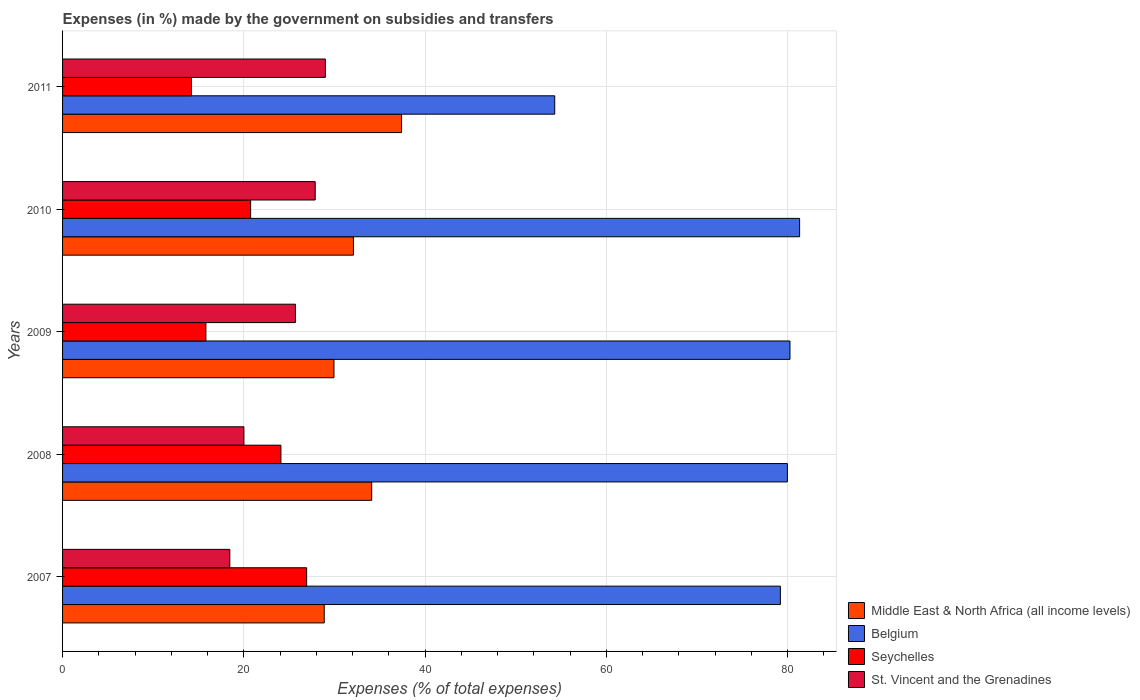How many groups of bars are there?
Provide a short and direct response. 5. Are the number of bars on each tick of the Y-axis equal?
Give a very brief answer. Yes. In how many cases, is the number of bars for a given year not equal to the number of legend labels?
Ensure brevity in your answer.  0. What is the percentage of expenses made by the government on subsidies and transfers in Belgium in 2011?
Make the answer very short. 54.3. Across all years, what is the maximum percentage of expenses made by the government on subsidies and transfers in Middle East & North Africa (all income levels)?
Keep it short and to the point. 37.4. Across all years, what is the minimum percentage of expenses made by the government on subsidies and transfers in Belgium?
Your response must be concise. 54.3. What is the total percentage of expenses made by the government on subsidies and transfers in Belgium in the graph?
Offer a very short reply. 375.04. What is the difference between the percentage of expenses made by the government on subsidies and transfers in Belgium in 2010 and that in 2011?
Provide a succinct answer. 27.02. What is the difference between the percentage of expenses made by the government on subsidies and transfers in Seychelles in 2009 and the percentage of expenses made by the government on subsidies and transfers in Middle East & North Africa (all income levels) in 2011?
Keep it short and to the point. -21.59. What is the average percentage of expenses made by the government on subsidies and transfers in Belgium per year?
Keep it short and to the point. 75.01. In the year 2007, what is the difference between the percentage of expenses made by the government on subsidies and transfers in Seychelles and percentage of expenses made by the government on subsidies and transfers in Belgium?
Ensure brevity in your answer.  -52.27. In how many years, is the percentage of expenses made by the government on subsidies and transfers in Middle East & North Africa (all income levels) greater than 40 %?
Ensure brevity in your answer.  0. What is the ratio of the percentage of expenses made by the government on subsidies and transfers in Belgium in 2009 to that in 2010?
Your response must be concise. 0.99. What is the difference between the highest and the second highest percentage of expenses made by the government on subsidies and transfers in Belgium?
Give a very brief answer. 1.06. What is the difference between the highest and the lowest percentage of expenses made by the government on subsidies and transfers in Belgium?
Give a very brief answer. 27.02. In how many years, is the percentage of expenses made by the government on subsidies and transfers in Middle East & North Africa (all income levels) greater than the average percentage of expenses made by the government on subsidies and transfers in Middle East & North Africa (all income levels) taken over all years?
Provide a succinct answer. 2. What does the 3rd bar from the top in 2007 represents?
Offer a very short reply. Belgium. What does the 3rd bar from the bottom in 2011 represents?
Your response must be concise. Seychelles. Is it the case that in every year, the sum of the percentage of expenses made by the government on subsidies and transfers in Belgium and percentage of expenses made by the government on subsidies and transfers in St. Vincent and the Grenadines is greater than the percentage of expenses made by the government on subsidies and transfers in Seychelles?
Ensure brevity in your answer.  Yes. How many bars are there?
Your response must be concise. 20. Are all the bars in the graph horizontal?
Your answer should be compact. Yes. How many years are there in the graph?
Your answer should be very brief. 5. What is the difference between two consecutive major ticks on the X-axis?
Provide a succinct answer. 20. What is the title of the graph?
Ensure brevity in your answer.  Expenses (in %) made by the government on subsidies and transfers. Does "Kosovo" appear as one of the legend labels in the graph?
Provide a short and direct response. No. What is the label or title of the X-axis?
Offer a very short reply. Expenses (% of total expenses). What is the Expenses (% of total expenses) of Middle East & North Africa (all income levels) in 2007?
Ensure brevity in your answer.  28.87. What is the Expenses (% of total expenses) of Belgium in 2007?
Make the answer very short. 79.2. What is the Expenses (% of total expenses) in Seychelles in 2007?
Your answer should be compact. 26.93. What is the Expenses (% of total expenses) in St. Vincent and the Grenadines in 2007?
Provide a succinct answer. 18.45. What is the Expenses (% of total expenses) in Middle East & North Africa (all income levels) in 2008?
Offer a terse response. 34.11. What is the Expenses (% of total expenses) of Belgium in 2008?
Provide a succinct answer. 79.97. What is the Expenses (% of total expenses) of Seychelles in 2008?
Give a very brief answer. 24.09. What is the Expenses (% of total expenses) of St. Vincent and the Grenadines in 2008?
Make the answer very short. 20.01. What is the Expenses (% of total expenses) in Middle East & North Africa (all income levels) in 2009?
Keep it short and to the point. 29.94. What is the Expenses (% of total expenses) of Belgium in 2009?
Ensure brevity in your answer.  80.26. What is the Expenses (% of total expenses) of Seychelles in 2009?
Make the answer very short. 15.81. What is the Expenses (% of total expenses) of St. Vincent and the Grenadines in 2009?
Make the answer very short. 25.69. What is the Expenses (% of total expenses) of Middle East & North Africa (all income levels) in 2010?
Give a very brief answer. 32.09. What is the Expenses (% of total expenses) of Belgium in 2010?
Provide a short and direct response. 81.32. What is the Expenses (% of total expenses) in Seychelles in 2010?
Keep it short and to the point. 20.75. What is the Expenses (% of total expenses) of St. Vincent and the Grenadines in 2010?
Provide a succinct answer. 27.87. What is the Expenses (% of total expenses) of Middle East & North Africa (all income levels) in 2011?
Provide a short and direct response. 37.4. What is the Expenses (% of total expenses) of Belgium in 2011?
Ensure brevity in your answer.  54.3. What is the Expenses (% of total expenses) of Seychelles in 2011?
Ensure brevity in your answer.  14.23. What is the Expenses (% of total expenses) of St. Vincent and the Grenadines in 2011?
Offer a very short reply. 29. Across all years, what is the maximum Expenses (% of total expenses) of Middle East & North Africa (all income levels)?
Ensure brevity in your answer.  37.4. Across all years, what is the maximum Expenses (% of total expenses) in Belgium?
Offer a very short reply. 81.32. Across all years, what is the maximum Expenses (% of total expenses) of Seychelles?
Provide a short and direct response. 26.93. Across all years, what is the maximum Expenses (% of total expenses) in St. Vincent and the Grenadines?
Ensure brevity in your answer.  29. Across all years, what is the minimum Expenses (% of total expenses) of Middle East & North Africa (all income levels)?
Keep it short and to the point. 28.87. Across all years, what is the minimum Expenses (% of total expenses) in Belgium?
Your answer should be very brief. 54.3. Across all years, what is the minimum Expenses (% of total expenses) in Seychelles?
Provide a short and direct response. 14.23. Across all years, what is the minimum Expenses (% of total expenses) in St. Vincent and the Grenadines?
Offer a very short reply. 18.45. What is the total Expenses (% of total expenses) of Middle East & North Africa (all income levels) in the graph?
Give a very brief answer. 162.42. What is the total Expenses (% of total expenses) in Belgium in the graph?
Keep it short and to the point. 375.04. What is the total Expenses (% of total expenses) of Seychelles in the graph?
Provide a succinct answer. 101.81. What is the total Expenses (% of total expenses) of St. Vincent and the Grenadines in the graph?
Your answer should be very brief. 121.03. What is the difference between the Expenses (% of total expenses) of Middle East & North Africa (all income levels) in 2007 and that in 2008?
Your answer should be very brief. -5.24. What is the difference between the Expenses (% of total expenses) of Belgium in 2007 and that in 2008?
Keep it short and to the point. -0.77. What is the difference between the Expenses (% of total expenses) in Seychelles in 2007 and that in 2008?
Provide a succinct answer. 2.84. What is the difference between the Expenses (% of total expenses) of St. Vincent and the Grenadines in 2007 and that in 2008?
Offer a very short reply. -1.56. What is the difference between the Expenses (% of total expenses) of Middle East & North Africa (all income levels) in 2007 and that in 2009?
Your answer should be very brief. -1.07. What is the difference between the Expenses (% of total expenses) in Belgium in 2007 and that in 2009?
Give a very brief answer. -1.06. What is the difference between the Expenses (% of total expenses) of Seychelles in 2007 and that in 2009?
Give a very brief answer. 11.11. What is the difference between the Expenses (% of total expenses) in St. Vincent and the Grenadines in 2007 and that in 2009?
Your response must be concise. -7.24. What is the difference between the Expenses (% of total expenses) in Middle East & North Africa (all income levels) in 2007 and that in 2010?
Provide a short and direct response. -3.22. What is the difference between the Expenses (% of total expenses) in Belgium in 2007 and that in 2010?
Provide a succinct answer. -2.12. What is the difference between the Expenses (% of total expenses) in Seychelles in 2007 and that in 2010?
Ensure brevity in your answer.  6.18. What is the difference between the Expenses (% of total expenses) in St. Vincent and the Grenadines in 2007 and that in 2010?
Offer a very short reply. -9.42. What is the difference between the Expenses (% of total expenses) of Middle East & North Africa (all income levels) in 2007 and that in 2011?
Give a very brief answer. -8.53. What is the difference between the Expenses (% of total expenses) in Belgium in 2007 and that in 2011?
Offer a terse response. 24.9. What is the difference between the Expenses (% of total expenses) of Seychelles in 2007 and that in 2011?
Ensure brevity in your answer.  12.7. What is the difference between the Expenses (% of total expenses) of St. Vincent and the Grenadines in 2007 and that in 2011?
Make the answer very short. -10.55. What is the difference between the Expenses (% of total expenses) of Middle East & North Africa (all income levels) in 2008 and that in 2009?
Give a very brief answer. 4.16. What is the difference between the Expenses (% of total expenses) of Belgium in 2008 and that in 2009?
Provide a short and direct response. -0.29. What is the difference between the Expenses (% of total expenses) of Seychelles in 2008 and that in 2009?
Offer a very short reply. 8.27. What is the difference between the Expenses (% of total expenses) of St. Vincent and the Grenadines in 2008 and that in 2009?
Your answer should be very brief. -5.68. What is the difference between the Expenses (% of total expenses) in Middle East & North Africa (all income levels) in 2008 and that in 2010?
Offer a very short reply. 2.02. What is the difference between the Expenses (% of total expenses) of Belgium in 2008 and that in 2010?
Give a very brief answer. -1.35. What is the difference between the Expenses (% of total expenses) of Seychelles in 2008 and that in 2010?
Offer a very short reply. 3.34. What is the difference between the Expenses (% of total expenses) of St. Vincent and the Grenadines in 2008 and that in 2010?
Your response must be concise. -7.86. What is the difference between the Expenses (% of total expenses) of Middle East & North Africa (all income levels) in 2008 and that in 2011?
Your answer should be compact. -3.29. What is the difference between the Expenses (% of total expenses) of Belgium in 2008 and that in 2011?
Offer a very short reply. 25.67. What is the difference between the Expenses (% of total expenses) of Seychelles in 2008 and that in 2011?
Keep it short and to the point. 9.86. What is the difference between the Expenses (% of total expenses) of St. Vincent and the Grenadines in 2008 and that in 2011?
Your answer should be very brief. -8.99. What is the difference between the Expenses (% of total expenses) in Middle East & North Africa (all income levels) in 2009 and that in 2010?
Make the answer very short. -2.15. What is the difference between the Expenses (% of total expenses) of Belgium in 2009 and that in 2010?
Provide a short and direct response. -1.06. What is the difference between the Expenses (% of total expenses) of Seychelles in 2009 and that in 2010?
Keep it short and to the point. -4.93. What is the difference between the Expenses (% of total expenses) of St. Vincent and the Grenadines in 2009 and that in 2010?
Make the answer very short. -2.18. What is the difference between the Expenses (% of total expenses) in Middle East & North Africa (all income levels) in 2009 and that in 2011?
Offer a very short reply. -7.46. What is the difference between the Expenses (% of total expenses) of Belgium in 2009 and that in 2011?
Offer a very short reply. 25.96. What is the difference between the Expenses (% of total expenses) in Seychelles in 2009 and that in 2011?
Your response must be concise. 1.59. What is the difference between the Expenses (% of total expenses) in St. Vincent and the Grenadines in 2009 and that in 2011?
Your answer should be very brief. -3.31. What is the difference between the Expenses (% of total expenses) in Middle East & North Africa (all income levels) in 2010 and that in 2011?
Provide a succinct answer. -5.31. What is the difference between the Expenses (% of total expenses) in Belgium in 2010 and that in 2011?
Offer a terse response. 27.02. What is the difference between the Expenses (% of total expenses) in Seychelles in 2010 and that in 2011?
Offer a very short reply. 6.52. What is the difference between the Expenses (% of total expenses) of St. Vincent and the Grenadines in 2010 and that in 2011?
Ensure brevity in your answer.  -1.12. What is the difference between the Expenses (% of total expenses) in Middle East & North Africa (all income levels) in 2007 and the Expenses (% of total expenses) in Belgium in 2008?
Make the answer very short. -51.1. What is the difference between the Expenses (% of total expenses) in Middle East & North Africa (all income levels) in 2007 and the Expenses (% of total expenses) in Seychelles in 2008?
Offer a terse response. 4.78. What is the difference between the Expenses (% of total expenses) in Middle East & North Africa (all income levels) in 2007 and the Expenses (% of total expenses) in St. Vincent and the Grenadines in 2008?
Keep it short and to the point. 8.86. What is the difference between the Expenses (% of total expenses) in Belgium in 2007 and the Expenses (% of total expenses) in Seychelles in 2008?
Offer a very short reply. 55.11. What is the difference between the Expenses (% of total expenses) of Belgium in 2007 and the Expenses (% of total expenses) of St. Vincent and the Grenadines in 2008?
Offer a terse response. 59.19. What is the difference between the Expenses (% of total expenses) in Seychelles in 2007 and the Expenses (% of total expenses) in St. Vincent and the Grenadines in 2008?
Your answer should be very brief. 6.92. What is the difference between the Expenses (% of total expenses) in Middle East & North Africa (all income levels) in 2007 and the Expenses (% of total expenses) in Belgium in 2009?
Ensure brevity in your answer.  -51.39. What is the difference between the Expenses (% of total expenses) in Middle East & North Africa (all income levels) in 2007 and the Expenses (% of total expenses) in Seychelles in 2009?
Your answer should be very brief. 13.06. What is the difference between the Expenses (% of total expenses) in Middle East & North Africa (all income levels) in 2007 and the Expenses (% of total expenses) in St. Vincent and the Grenadines in 2009?
Provide a short and direct response. 3.18. What is the difference between the Expenses (% of total expenses) in Belgium in 2007 and the Expenses (% of total expenses) in Seychelles in 2009?
Provide a short and direct response. 63.38. What is the difference between the Expenses (% of total expenses) of Belgium in 2007 and the Expenses (% of total expenses) of St. Vincent and the Grenadines in 2009?
Your answer should be compact. 53.5. What is the difference between the Expenses (% of total expenses) in Seychelles in 2007 and the Expenses (% of total expenses) in St. Vincent and the Grenadines in 2009?
Provide a succinct answer. 1.24. What is the difference between the Expenses (% of total expenses) of Middle East & North Africa (all income levels) in 2007 and the Expenses (% of total expenses) of Belgium in 2010?
Your response must be concise. -52.45. What is the difference between the Expenses (% of total expenses) in Middle East & North Africa (all income levels) in 2007 and the Expenses (% of total expenses) in Seychelles in 2010?
Your answer should be compact. 8.12. What is the difference between the Expenses (% of total expenses) of Middle East & North Africa (all income levels) in 2007 and the Expenses (% of total expenses) of St. Vincent and the Grenadines in 2010?
Your answer should be very brief. 1. What is the difference between the Expenses (% of total expenses) in Belgium in 2007 and the Expenses (% of total expenses) in Seychelles in 2010?
Your answer should be very brief. 58.45. What is the difference between the Expenses (% of total expenses) of Belgium in 2007 and the Expenses (% of total expenses) of St. Vincent and the Grenadines in 2010?
Provide a short and direct response. 51.32. What is the difference between the Expenses (% of total expenses) of Seychelles in 2007 and the Expenses (% of total expenses) of St. Vincent and the Grenadines in 2010?
Your answer should be very brief. -0.95. What is the difference between the Expenses (% of total expenses) of Middle East & North Africa (all income levels) in 2007 and the Expenses (% of total expenses) of Belgium in 2011?
Make the answer very short. -25.43. What is the difference between the Expenses (% of total expenses) of Middle East & North Africa (all income levels) in 2007 and the Expenses (% of total expenses) of Seychelles in 2011?
Your answer should be very brief. 14.65. What is the difference between the Expenses (% of total expenses) in Middle East & North Africa (all income levels) in 2007 and the Expenses (% of total expenses) in St. Vincent and the Grenadines in 2011?
Offer a terse response. -0.13. What is the difference between the Expenses (% of total expenses) in Belgium in 2007 and the Expenses (% of total expenses) in Seychelles in 2011?
Make the answer very short. 64.97. What is the difference between the Expenses (% of total expenses) in Belgium in 2007 and the Expenses (% of total expenses) in St. Vincent and the Grenadines in 2011?
Provide a short and direct response. 50.2. What is the difference between the Expenses (% of total expenses) of Seychelles in 2007 and the Expenses (% of total expenses) of St. Vincent and the Grenadines in 2011?
Your response must be concise. -2.07. What is the difference between the Expenses (% of total expenses) in Middle East & North Africa (all income levels) in 2008 and the Expenses (% of total expenses) in Belgium in 2009?
Make the answer very short. -46.15. What is the difference between the Expenses (% of total expenses) in Middle East & North Africa (all income levels) in 2008 and the Expenses (% of total expenses) in Seychelles in 2009?
Provide a short and direct response. 18.29. What is the difference between the Expenses (% of total expenses) of Middle East & North Africa (all income levels) in 2008 and the Expenses (% of total expenses) of St. Vincent and the Grenadines in 2009?
Your answer should be very brief. 8.42. What is the difference between the Expenses (% of total expenses) of Belgium in 2008 and the Expenses (% of total expenses) of Seychelles in 2009?
Ensure brevity in your answer.  64.16. What is the difference between the Expenses (% of total expenses) in Belgium in 2008 and the Expenses (% of total expenses) in St. Vincent and the Grenadines in 2009?
Your answer should be very brief. 54.28. What is the difference between the Expenses (% of total expenses) of Seychelles in 2008 and the Expenses (% of total expenses) of St. Vincent and the Grenadines in 2009?
Your answer should be very brief. -1.6. What is the difference between the Expenses (% of total expenses) of Middle East & North Africa (all income levels) in 2008 and the Expenses (% of total expenses) of Belgium in 2010?
Offer a terse response. -47.21. What is the difference between the Expenses (% of total expenses) of Middle East & North Africa (all income levels) in 2008 and the Expenses (% of total expenses) of Seychelles in 2010?
Make the answer very short. 13.36. What is the difference between the Expenses (% of total expenses) in Middle East & North Africa (all income levels) in 2008 and the Expenses (% of total expenses) in St. Vincent and the Grenadines in 2010?
Provide a short and direct response. 6.23. What is the difference between the Expenses (% of total expenses) in Belgium in 2008 and the Expenses (% of total expenses) in Seychelles in 2010?
Offer a terse response. 59.22. What is the difference between the Expenses (% of total expenses) in Belgium in 2008 and the Expenses (% of total expenses) in St. Vincent and the Grenadines in 2010?
Keep it short and to the point. 52.1. What is the difference between the Expenses (% of total expenses) in Seychelles in 2008 and the Expenses (% of total expenses) in St. Vincent and the Grenadines in 2010?
Offer a terse response. -3.78. What is the difference between the Expenses (% of total expenses) in Middle East & North Africa (all income levels) in 2008 and the Expenses (% of total expenses) in Belgium in 2011?
Offer a very short reply. -20.19. What is the difference between the Expenses (% of total expenses) in Middle East & North Africa (all income levels) in 2008 and the Expenses (% of total expenses) in Seychelles in 2011?
Provide a short and direct response. 19.88. What is the difference between the Expenses (% of total expenses) of Middle East & North Africa (all income levels) in 2008 and the Expenses (% of total expenses) of St. Vincent and the Grenadines in 2011?
Your response must be concise. 5.11. What is the difference between the Expenses (% of total expenses) in Belgium in 2008 and the Expenses (% of total expenses) in Seychelles in 2011?
Make the answer very short. 65.75. What is the difference between the Expenses (% of total expenses) of Belgium in 2008 and the Expenses (% of total expenses) of St. Vincent and the Grenadines in 2011?
Your answer should be compact. 50.97. What is the difference between the Expenses (% of total expenses) in Seychelles in 2008 and the Expenses (% of total expenses) in St. Vincent and the Grenadines in 2011?
Make the answer very short. -4.91. What is the difference between the Expenses (% of total expenses) of Middle East & North Africa (all income levels) in 2009 and the Expenses (% of total expenses) of Belgium in 2010?
Your answer should be very brief. -51.37. What is the difference between the Expenses (% of total expenses) in Middle East & North Africa (all income levels) in 2009 and the Expenses (% of total expenses) in Seychelles in 2010?
Offer a very short reply. 9.2. What is the difference between the Expenses (% of total expenses) in Middle East & North Africa (all income levels) in 2009 and the Expenses (% of total expenses) in St. Vincent and the Grenadines in 2010?
Provide a succinct answer. 2.07. What is the difference between the Expenses (% of total expenses) in Belgium in 2009 and the Expenses (% of total expenses) in Seychelles in 2010?
Provide a short and direct response. 59.51. What is the difference between the Expenses (% of total expenses) in Belgium in 2009 and the Expenses (% of total expenses) in St. Vincent and the Grenadines in 2010?
Ensure brevity in your answer.  52.38. What is the difference between the Expenses (% of total expenses) of Seychelles in 2009 and the Expenses (% of total expenses) of St. Vincent and the Grenadines in 2010?
Make the answer very short. -12.06. What is the difference between the Expenses (% of total expenses) in Middle East & North Africa (all income levels) in 2009 and the Expenses (% of total expenses) in Belgium in 2011?
Offer a terse response. -24.36. What is the difference between the Expenses (% of total expenses) in Middle East & North Africa (all income levels) in 2009 and the Expenses (% of total expenses) in Seychelles in 2011?
Offer a very short reply. 15.72. What is the difference between the Expenses (% of total expenses) of Middle East & North Africa (all income levels) in 2009 and the Expenses (% of total expenses) of St. Vincent and the Grenadines in 2011?
Provide a succinct answer. 0.95. What is the difference between the Expenses (% of total expenses) in Belgium in 2009 and the Expenses (% of total expenses) in Seychelles in 2011?
Make the answer very short. 66.03. What is the difference between the Expenses (% of total expenses) of Belgium in 2009 and the Expenses (% of total expenses) of St. Vincent and the Grenadines in 2011?
Provide a short and direct response. 51.26. What is the difference between the Expenses (% of total expenses) of Seychelles in 2009 and the Expenses (% of total expenses) of St. Vincent and the Grenadines in 2011?
Give a very brief answer. -13.18. What is the difference between the Expenses (% of total expenses) of Middle East & North Africa (all income levels) in 2010 and the Expenses (% of total expenses) of Belgium in 2011?
Keep it short and to the point. -22.21. What is the difference between the Expenses (% of total expenses) in Middle East & North Africa (all income levels) in 2010 and the Expenses (% of total expenses) in Seychelles in 2011?
Ensure brevity in your answer.  17.87. What is the difference between the Expenses (% of total expenses) of Middle East & North Africa (all income levels) in 2010 and the Expenses (% of total expenses) of St. Vincent and the Grenadines in 2011?
Your answer should be compact. 3.09. What is the difference between the Expenses (% of total expenses) in Belgium in 2010 and the Expenses (% of total expenses) in Seychelles in 2011?
Ensure brevity in your answer.  67.09. What is the difference between the Expenses (% of total expenses) in Belgium in 2010 and the Expenses (% of total expenses) in St. Vincent and the Grenadines in 2011?
Provide a short and direct response. 52.32. What is the difference between the Expenses (% of total expenses) of Seychelles in 2010 and the Expenses (% of total expenses) of St. Vincent and the Grenadines in 2011?
Offer a terse response. -8.25. What is the average Expenses (% of total expenses) in Middle East & North Africa (all income levels) per year?
Your answer should be very brief. 32.48. What is the average Expenses (% of total expenses) in Belgium per year?
Give a very brief answer. 75.01. What is the average Expenses (% of total expenses) in Seychelles per year?
Your answer should be very brief. 20.36. What is the average Expenses (% of total expenses) in St. Vincent and the Grenadines per year?
Provide a short and direct response. 24.21. In the year 2007, what is the difference between the Expenses (% of total expenses) of Middle East & North Africa (all income levels) and Expenses (% of total expenses) of Belgium?
Offer a very short reply. -50.33. In the year 2007, what is the difference between the Expenses (% of total expenses) of Middle East & North Africa (all income levels) and Expenses (% of total expenses) of Seychelles?
Offer a terse response. 1.94. In the year 2007, what is the difference between the Expenses (% of total expenses) of Middle East & North Africa (all income levels) and Expenses (% of total expenses) of St. Vincent and the Grenadines?
Your response must be concise. 10.42. In the year 2007, what is the difference between the Expenses (% of total expenses) in Belgium and Expenses (% of total expenses) in Seychelles?
Give a very brief answer. 52.27. In the year 2007, what is the difference between the Expenses (% of total expenses) of Belgium and Expenses (% of total expenses) of St. Vincent and the Grenadines?
Provide a short and direct response. 60.74. In the year 2007, what is the difference between the Expenses (% of total expenses) in Seychelles and Expenses (% of total expenses) in St. Vincent and the Grenadines?
Give a very brief answer. 8.48. In the year 2008, what is the difference between the Expenses (% of total expenses) of Middle East & North Africa (all income levels) and Expenses (% of total expenses) of Belgium?
Ensure brevity in your answer.  -45.86. In the year 2008, what is the difference between the Expenses (% of total expenses) in Middle East & North Africa (all income levels) and Expenses (% of total expenses) in Seychelles?
Your answer should be very brief. 10.02. In the year 2008, what is the difference between the Expenses (% of total expenses) in Middle East & North Africa (all income levels) and Expenses (% of total expenses) in St. Vincent and the Grenadines?
Provide a succinct answer. 14.1. In the year 2008, what is the difference between the Expenses (% of total expenses) in Belgium and Expenses (% of total expenses) in Seychelles?
Provide a short and direct response. 55.88. In the year 2008, what is the difference between the Expenses (% of total expenses) in Belgium and Expenses (% of total expenses) in St. Vincent and the Grenadines?
Provide a succinct answer. 59.96. In the year 2008, what is the difference between the Expenses (% of total expenses) of Seychelles and Expenses (% of total expenses) of St. Vincent and the Grenadines?
Offer a very short reply. 4.08. In the year 2009, what is the difference between the Expenses (% of total expenses) of Middle East & North Africa (all income levels) and Expenses (% of total expenses) of Belgium?
Give a very brief answer. -50.31. In the year 2009, what is the difference between the Expenses (% of total expenses) of Middle East & North Africa (all income levels) and Expenses (% of total expenses) of Seychelles?
Ensure brevity in your answer.  14.13. In the year 2009, what is the difference between the Expenses (% of total expenses) in Middle East & North Africa (all income levels) and Expenses (% of total expenses) in St. Vincent and the Grenadines?
Your answer should be compact. 4.25. In the year 2009, what is the difference between the Expenses (% of total expenses) of Belgium and Expenses (% of total expenses) of Seychelles?
Offer a terse response. 64.44. In the year 2009, what is the difference between the Expenses (% of total expenses) in Belgium and Expenses (% of total expenses) in St. Vincent and the Grenadines?
Offer a very short reply. 54.56. In the year 2009, what is the difference between the Expenses (% of total expenses) in Seychelles and Expenses (% of total expenses) in St. Vincent and the Grenadines?
Offer a very short reply. -9.88. In the year 2010, what is the difference between the Expenses (% of total expenses) in Middle East & North Africa (all income levels) and Expenses (% of total expenses) in Belgium?
Offer a terse response. -49.23. In the year 2010, what is the difference between the Expenses (% of total expenses) of Middle East & North Africa (all income levels) and Expenses (% of total expenses) of Seychelles?
Offer a terse response. 11.34. In the year 2010, what is the difference between the Expenses (% of total expenses) of Middle East & North Africa (all income levels) and Expenses (% of total expenses) of St. Vincent and the Grenadines?
Provide a short and direct response. 4.22. In the year 2010, what is the difference between the Expenses (% of total expenses) of Belgium and Expenses (% of total expenses) of Seychelles?
Your response must be concise. 60.57. In the year 2010, what is the difference between the Expenses (% of total expenses) of Belgium and Expenses (% of total expenses) of St. Vincent and the Grenadines?
Your answer should be very brief. 53.44. In the year 2010, what is the difference between the Expenses (% of total expenses) of Seychelles and Expenses (% of total expenses) of St. Vincent and the Grenadines?
Provide a succinct answer. -7.13. In the year 2011, what is the difference between the Expenses (% of total expenses) in Middle East & North Africa (all income levels) and Expenses (% of total expenses) in Belgium?
Your answer should be compact. -16.9. In the year 2011, what is the difference between the Expenses (% of total expenses) in Middle East & North Africa (all income levels) and Expenses (% of total expenses) in Seychelles?
Offer a terse response. 23.18. In the year 2011, what is the difference between the Expenses (% of total expenses) in Middle East & North Africa (all income levels) and Expenses (% of total expenses) in St. Vincent and the Grenadines?
Offer a very short reply. 8.4. In the year 2011, what is the difference between the Expenses (% of total expenses) of Belgium and Expenses (% of total expenses) of Seychelles?
Keep it short and to the point. 40.08. In the year 2011, what is the difference between the Expenses (% of total expenses) in Belgium and Expenses (% of total expenses) in St. Vincent and the Grenadines?
Offer a terse response. 25.3. In the year 2011, what is the difference between the Expenses (% of total expenses) in Seychelles and Expenses (% of total expenses) in St. Vincent and the Grenadines?
Make the answer very short. -14.77. What is the ratio of the Expenses (% of total expenses) of Middle East & North Africa (all income levels) in 2007 to that in 2008?
Give a very brief answer. 0.85. What is the ratio of the Expenses (% of total expenses) in Belgium in 2007 to that in 2008?
Provide a succinct answer. 0.99. What is the ratio of the Expenses (% of total expenses) of Seychelles in 2007 to that in 2008?
Offer a terse response. 1.12. What is the ratio of the Expenses (% of total expenses) of St. Vincent and the Grenadines in 2007 to that in 2008?
Provide a short and direct response. 0.92. What is the ratio of the Expenses (% of total expenses) of Middle East & North Africa (all income levels) in 2007 to that in 2009?
Your answer should be compact. 0.96. What is the ratio of the Expenses (% of total expenses) in Belgium in 2007 to that in 2009?
Your answer should be compact. 0.99. What is the ratio of the Expenses (% of total expenses) in Seychelles in 2007 to that in 2009?
Keep it short and to the point. 1.7. What is the ratio of the Expenses (% of total expenses) of St. Vincent and the Grenadines in 2007 to that in 2009?
Provide a short and direct response. 0.72. What is the ratio of the Expenses (% of total expenses) of Middle East & North Africa (all income levels) in 2007 to that in 2010?
Provide a short and direct response. 0.9. What is the ratio of the Expenses (% of total expenses) of Belgium in 2007 to that in 2010?
Keep it short and to the point. 0.97. What is the ratio of the Expenses (% of total expenses) of Seychelles in 2007 to that in 2010?
Make the answer very short. 1.3. What is the ratio of the Expenses (% of total expenses) in St. Vincent and the Grenadines in 2007 to that in 2010?
Your answer should be very brief. 0.66. What is the ratio of the Expenses (% of total expenses) of Middle East & North Africa (all income levels) in 2007 to that in 2011?
Give a very brief answer. 0.77. What is the ratio of the Expenses (% of total expenses) in Belgium in 2007 to that in 2011?
Your answer should be compact. 1.46. What is the ratio of the Expenses (% of total expenses) in Seychelles in 2007 to that in 2011?
Keep it short and to the point. 1.89. What is the ratio of the Expenses (% of total expenses) in St. Vincent and the Grenadines in 2007 to that in 2011?
Give a very brief answer. 0.64. What is the ratio of the Expenses (% of total expenses) in Middle East & North Africa (all income levels) in 2008 to that in 2009?
Offer a very short reply. 1.14. What is the ratio of the Expenses (% of total expenses) in Seychelles in 2008 to that in 2009?
Ensure brevity in your answer.  1.52. What is the ratio of the Expenses (% of total expenses) in St. Vincent and the Grenadines in 2008 to that in 2009?
Keep it short and to the point. 0.78. What is the ratio of the Expenses (% of total expenses) of Middle East & North Africa (all income levels) in 2008 to that in 2010?
Your response must be concise. 1.06. What is the ratio of the Expenses (% of total expenses) in Belgium in 2008 to that in 2010?
Provide a short and direct response. 0.98. What is the ratio of the Expenses (% of total expenses) of Seychelles in 2008 to that in 2010?
Your answer should be compact. 1.16. What is the ratio of the Expenses (% of total expenses) in St. Vincent and the Grenadines in 2008 to that in 2010?
Give a very brief answer. 0.72. What is the ratio of the Expenses (% of total expenses) of Middle East & North Africa (all income levels) in 2008 to that in 2011?
Ensure brevity in your answer.  0.91. What is the ratio of the Expenses (% of total expenses) of Belgium in 2008 to that in 2011?
Your answer should be very brief. 1.47. What is the ratio of the Expenses (% of total expenses) of Seychelles in 2008 to that in 2011?
Provide a short and direct response. 1.69. What is the ratio of the Expenses (% of total expenses) of St. Vincent and the Grenadines in 2008 to that in 2011?
Your answer should be very brief. 0.69. What is the ratio of the Expenses (% of total expenses) in Middle East & North Africa (all income levels) in 2009 to that in 2010?
Your answer should be very brief. 0.93. What is the ratio of the Expenses (% of total expenses) of Belgium in 2009 to that in 2010?
Your response must be concise. 0.99. What is the ratio of the Expenses (% of total expenses) of Seychelles in 2009 to that in 2010?
Your answer should be compact. 0.76. What is the ratio of the Expenses (% of total expenses) in St. Vincent and the Grenadines in 2009 to that in 2010?
Your answer should be very brief. 0.92. What is the ratio of the Expenses (% of total expenses) in Middle East & North Africa (all income levels) in 2009 to that in 2011?
Provide a succinct answer. 0.8. What is the ratio of the Expenses (% of total expenses) in Belgium in 2009 to that in 2011?
Provide a short and direct response. 1.48. What is the ratio of the Expenses (% of total expenses) in Seychelles in 2009 to that in 2011?
Provide a short and direct response. 1.11. What is the ratio of the Expenses (% of total expenses) of St. Vincent and the Grenadines in 2009 to that in 2011?
Keep it short and to the point. 0.89. What is the ratio of the Expenses (% of total expenses) of Middle East & North Africa (all income levels) in 2010 to that in 2011?
Your answer should be very brief. 0.86. What is the ratio of the Expenses (% of total expenses) of Belgium in 2010 to that in 2011?
Give a very brief answer. 1.5. What is the ratio of the Expenses (% of total expenses) of Seychelles in 2010 to that in 2011?
Provide a succinct answer. 1.46. What is the ratio of the Expenses (% of total expenses) of St. Vincent and the Grenadines in 2010 to that in 2011?
Ensure brevity in your answer.  0.96. What is the difference between the highest and the second highest Expenses (% of total expenses) in Middle East & North Africa (all income levels)?
Offer a terse response. 3.29. What is the difference between the highest and the second highest Expenses (% of total expenses) of Belgium?
Your answer should be very brief. 1.06. What is the difference between the highest and the second highest Expenses (% of total expenses) in Seychelles?
Give a very brief answer. 2.84. What is the difference between the highest and the second highest Expenses (% of total expenses) in St. Vincent and the Grenadines?
Give a very brief answer. 1.12. What is the difference between the highest and the lowest Expenses (% of total expenses) in Middle East & North Africa (all income levels)?
Your answer should be compact. 8.53. What is the difference between the highest and the lowest Expenses (% of total expenses) of Belgium?
Keep it short and to the point. 27.02. What is the difference between the highest and the lowest Expenses (% of total expenses) in Seychelles?
Provide a succinct answer. 12.7. What is the difference between the highest and the lowest Expenses (% of total expenses) of St. Vincent and the Grenadines?
Provide a succinct answer. 10.55. 